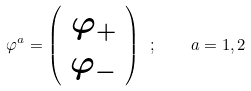Convert formula to latex. <formula><loc_0><loc_0><loc_500><loc_500>\varphi ^ { a } = \left ( \begin{array} { c } { { \varphi _ { + } } } \\ { { \varphi _ { - } } } \end{array} \right ) \ ; \quad a = 1 , 2 \</formula> 